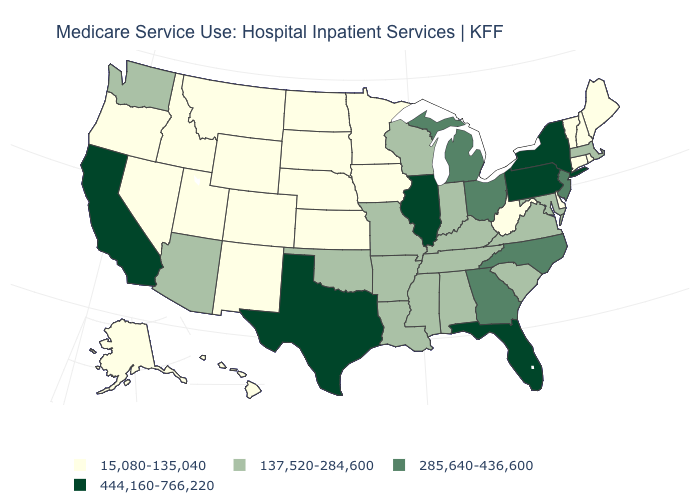Name the states that have a value in the range 137,520-284,600?
Give a very brief answer. Alabama, Arizona, Arkansas, Indiana, Kentucky, Louisiana, Maryland, Massachusetts, Mississippi, Missouri, Oklahoma, South Carolina, Tennessee, Virginia, Washington, Wisconsin. What is the value of Wyoming?
Keep it brief. 15,080-135,040. Does California have a higher value than New Hampshire?
Give a very brief answer. Yes. Name the states that have a value in the range 444,160-766,220?
Quick response, please. California, Florida, Illinois, New York, Pennsylvania, Texas. Does the first symbol in the legend represent the smallest category?
Concise answer only. Yes. Name the states that have a value in the range 444,160-766,220?
Concise answer only. California, Florida, Illinois, New York, Pennsylvania, Texas. What is the value of Delaware?
Give a very brief answer. 15,080-135,040. What is the lowest value in the USA?
Concise answer only. 15,080-135,040. Does Pennsylvania have the highest value in the USA?
Concise answer only. Yes. What is the value of Kentucky?
Give a very brief answer. 137,520-284,600. Which states have the highest value in the USA?
Short answer required. California, Florida, Illinois, New York, Pennsylvania, Texas. Among the states that border Kentucky , which have the lowest value?
Answer briefly. West Virginia. Does Vermont have the same value as Minnesota?
Answer briefly. Yes. Which states hav the highest value in the MidWest?
Quick response, please. Illinois. Which states have the lowest value in the South?
Keep it brief. Delaware, West Virginia. 